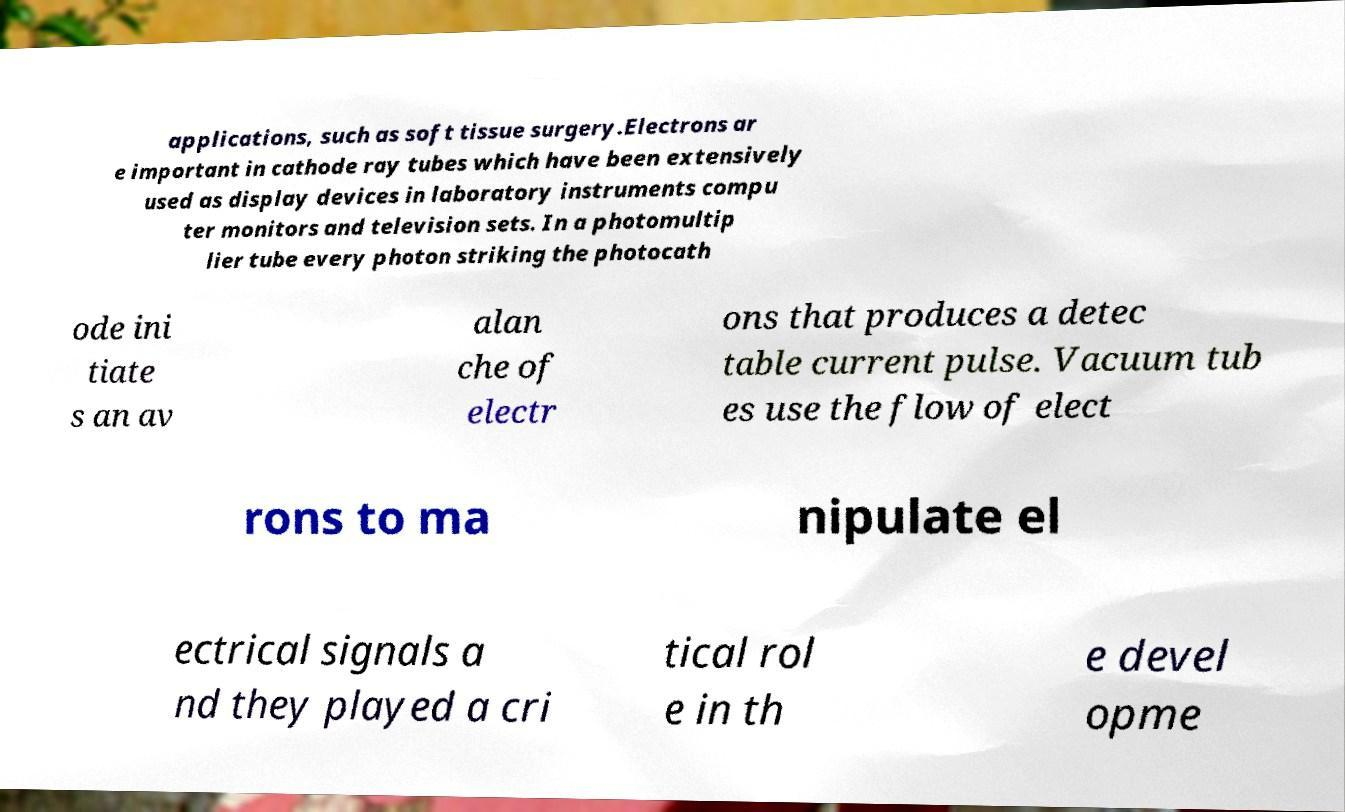What messages or text are displayed in this image? I need them in a readable, typed format. applications, such as soft tissue surgery.Electrons ar e important in cathode ray tubes which have been extensively used as display devices in laboratory instruments compu ter monitors and television sets. In a photomultip lier tube every photon striking the photocath ode ini tiate s an av alan che of electr ons that produces a detec table current pulse. Vacuum tub es use the flow of elect rons to ma nipulate el ectrical signals a nd they played a cri tical rol e in th e devel opme 